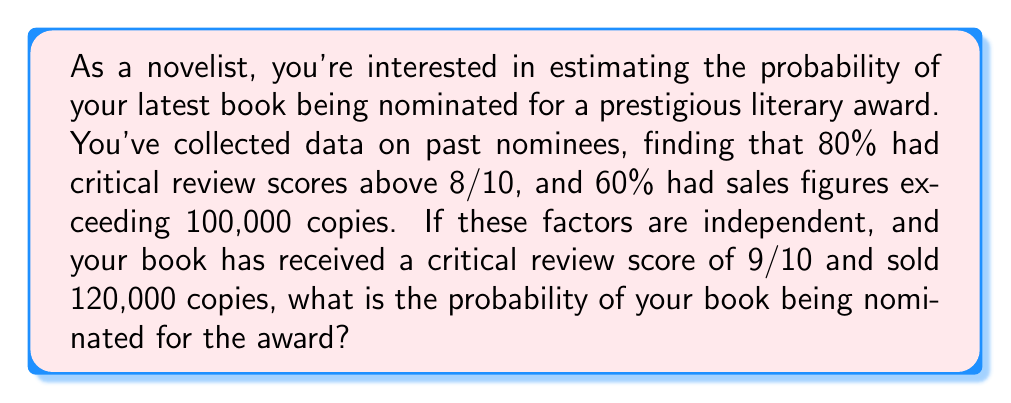Show me your answer to this math problem. Let's approach this step-by-step:

1) First, we need to identify the given probabilities:
   - P(R) = Probability of having a review score above 8/10 = 0.80
   - P(S) = Probability of having sales figures above 100,000 = 0.60

2) We're told that these factors are independent. This means we can use the multiplication rule of probability for independent events.

3) The probability of both events occurring simultaneously is:

   $$P(R \text{ and } S) = P(R) \times P(S)$$

4) Substituting the values:

   $$P(R \text{ and } S) = 0.80 \times 0.60 = 0.48$$

5) This means that 48% of nominated books have both high review scores and high sales figures.

6) Since your book meets both criteria (review score of 9/10 and sales of 120,000), it falls into this category.

7) Therefore, the probability of your book being nominated, given that it meets both criteria, is 0.48 or 48%.
Answer: 0.48 